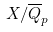Convert formula to latex. <formula><loc_0><loc_0><loc_500><loc_500>X / { \overline { Q } } _ { p }</formula> 